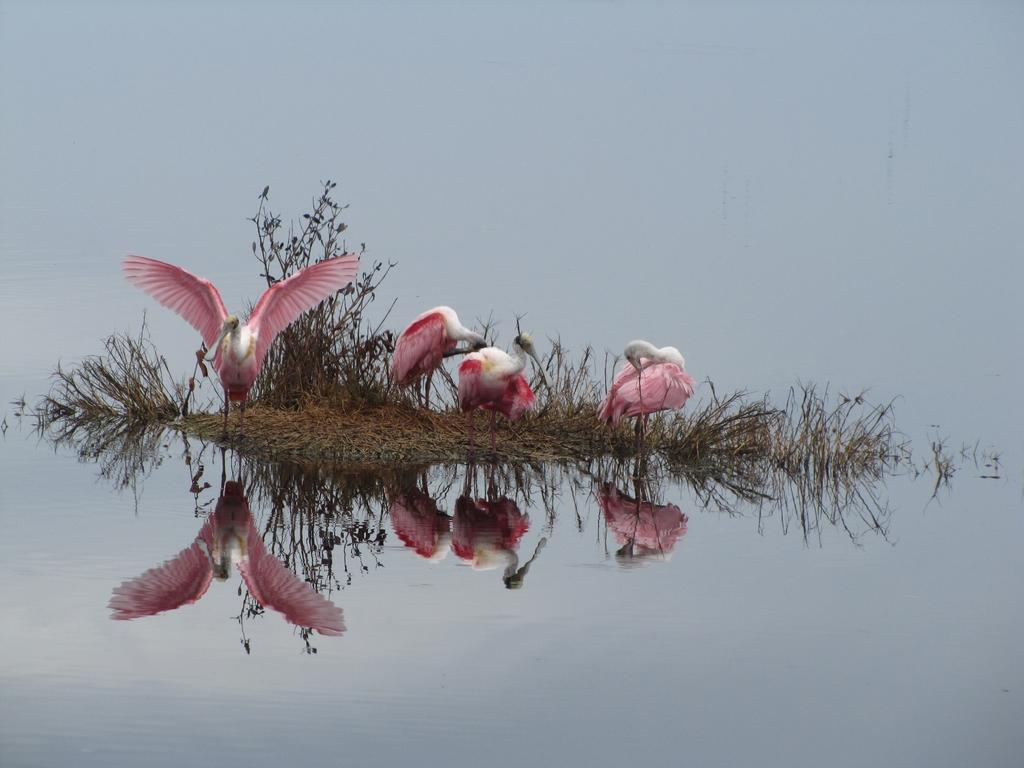What type of animals can be seen in the image? There are birds in the image. What colors are the birds in the image? The birds are in pink and white color. What type of vegetation is present in the image? There is dry grass in the image. What else can be seen in the image besides the birds and dry grass? There is water visible in the image. Can you tell me how the minister is pushing the insect in the image? There is no minister or insect present in the image. 